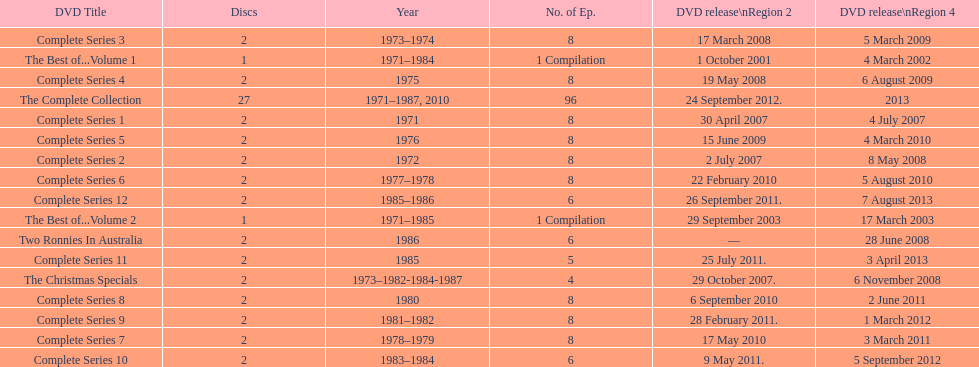What is the sum of episodes that came out in region 2 in the year 2007? 20. 